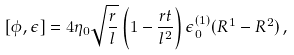<formula> <loc_0><loc_0><loc_500><loc_500>[ \phi , \epsilon ] = 4 \eta _ { 0 } \sqrt { \frac { r } { l } } \left ( 1 - \frac { r t } { l ^ { 2 } } \right ) \epsilon _ { 0 } ^ { ( 1 ) } ( R ^ { 1 } - R ^ { 2 } ) \, ,</formula> 